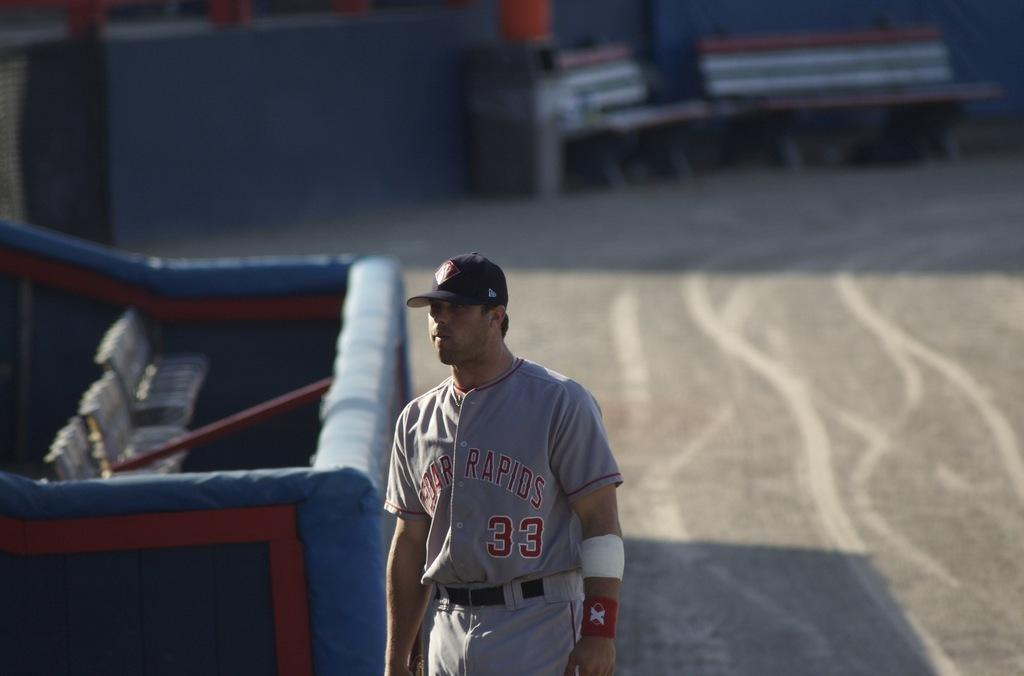Who is in the image? There is a man in the image. What is the man wearing? The man is wearing a gray dress and a cap. What can be seen in the background of the image? There are benches in the background of the image. What is on the left side of the image? There is a box on the left side of the image. What is inside the box? The box contains benches. What type of twig can be seen in the man's hand in the image? There is no twig present in the man's hand or in the image. What thrilling activity is the man participating in while wearing the gray dress and cap? The image does not depict any specific activity or thrill; it simply shows a man wearing a gray dress and cap with a box and benches in the background. 